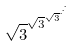Convert formula to latex. <formula><loc_0><loc_0><loc_500><loc_500>\sqrt { 3 } ^ { \sqrt { 3 } ^ { \sqrt { 3 } ^ { \cdot ^ { \cdot ^ { \cdot } } } } }</formula> 